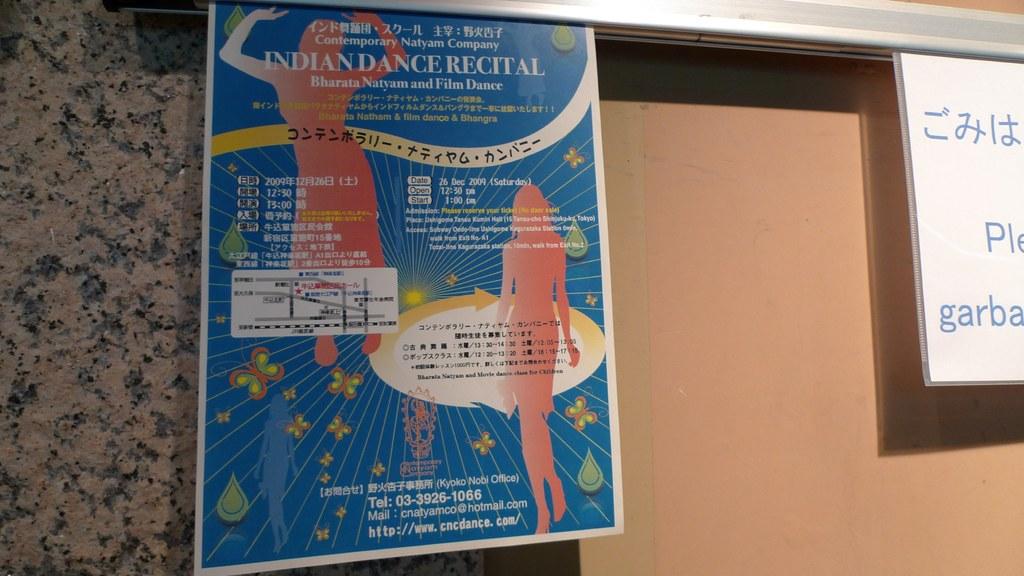What kind of dance recital?
Keep it short and to the point. Indian. 